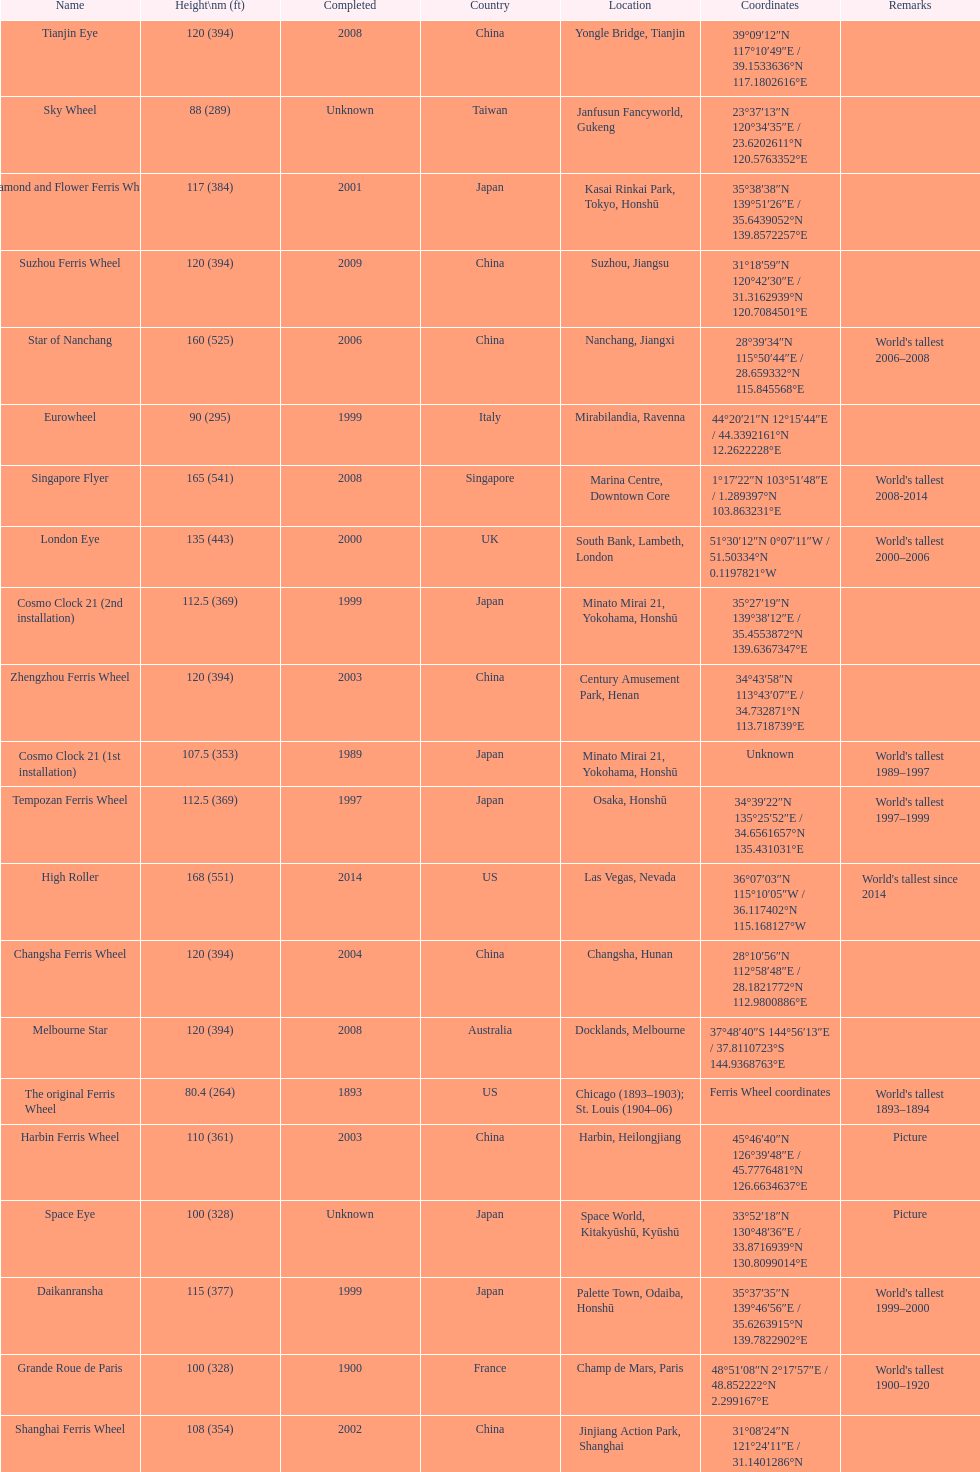Which country had the most roller coasters over 80 feet in height in 2008? China. 